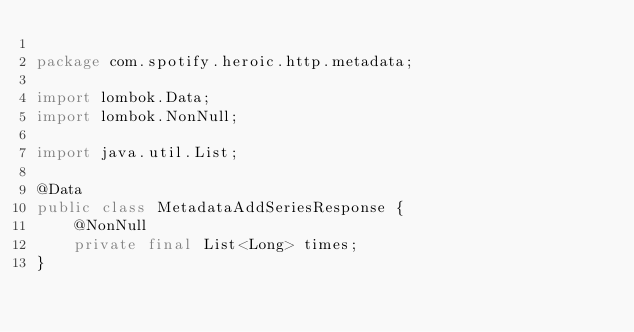<code> <loc_0><loc_0><loc_500><loc_500><_Java_>
package com.spotify.heroic.http.metadata;

import lombok.Data;
import lombok.NonNull;

import java.util.List;

@Data
public class MetadataAddSeriesResponse {
    @NonNull
    private final List<Long> times;
}
</code> 